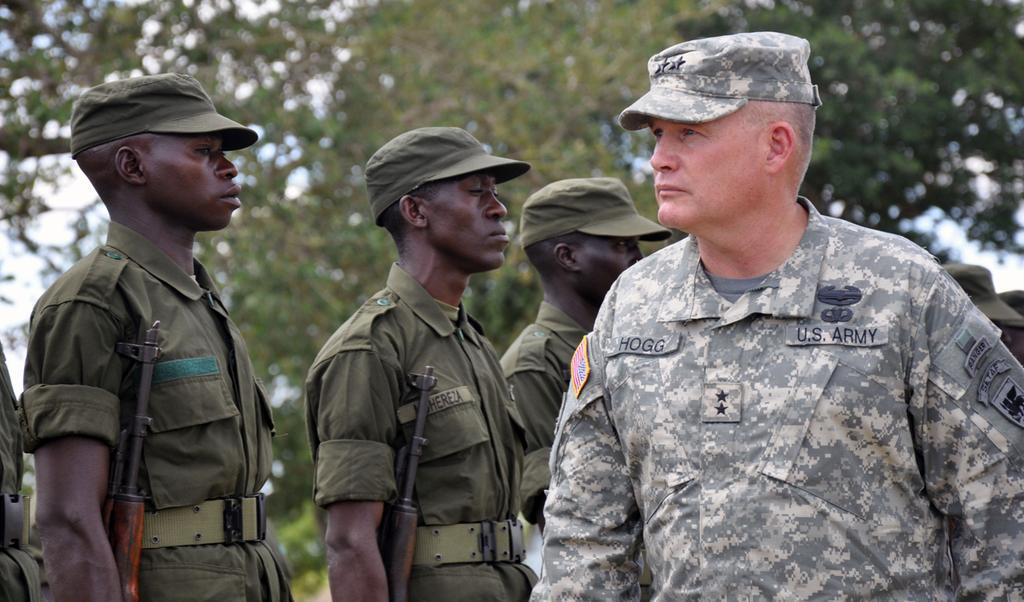Could you give a brief overview of what you see in this image? In this picture I can see on the right side there is a man, he is wearing an army dress, cap. On the left side three men are standing by holding the weapons, in the background there are trees. 